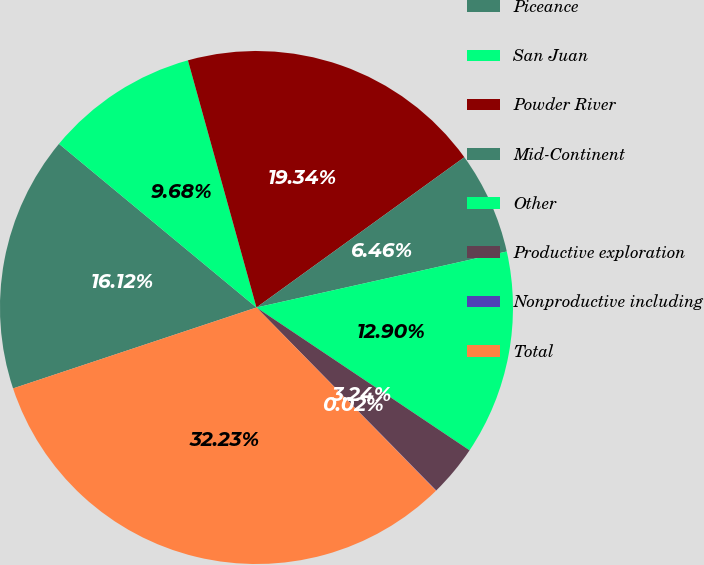Convert chart to OTSL. <chart><loc_0><loc_0><loc_500><loc_500><pie_chart><fcel>Piceance<fcel>San Juan<fcel>Powder River<fcel>Mid-Continent<fcel>Other<fcel>Productive exploration<fcel>Nonproductive including<fcel>Total<nl><fcel>16.12%<fcel>9.68%<fcel>19.34%<fcel>6.46%<fcel>12.9%<fcel>3.24%<fcel>0.02%<fcel>32.23%<nl></chart> 